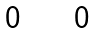Convert formula to latex. <formula><loc_0><loc_0><loc_500><loc_500>\begin{matrix} 0 & \quad \, 0 \end{matrix}</formula> 